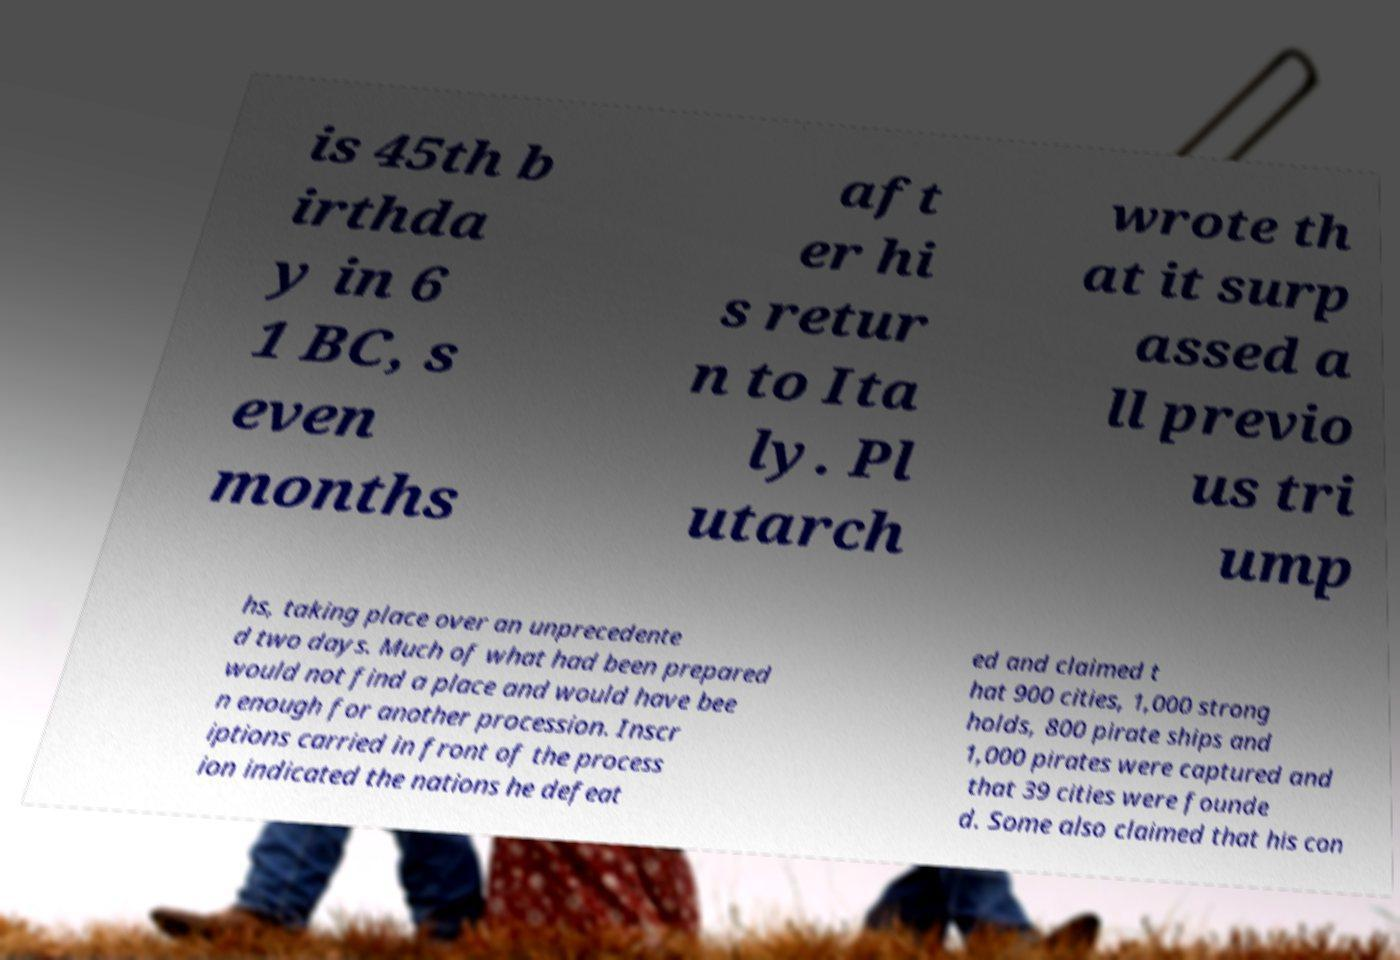There's text embedded in this image that I need extracted. Can you transcribe it verbatim? is 45th b irthda y in 6 1 BC, s even months aft er hi s retur n to Ita ly. Pl utarch wrote th at it surp assed a ll previo us tri ump hs, taking place over an unprecedente d two days. Much of what had been prepared would not find a place and would have bee n enough for another procession. Inscr iptions carried in front of the process ion indicated the nations he defeat ed and claimed t hat 900 cities, 1,000 strong holds, 800 pirate ships and 1,000 pirates were captured and that 39 cities were founde d. Some also claimed that his con 